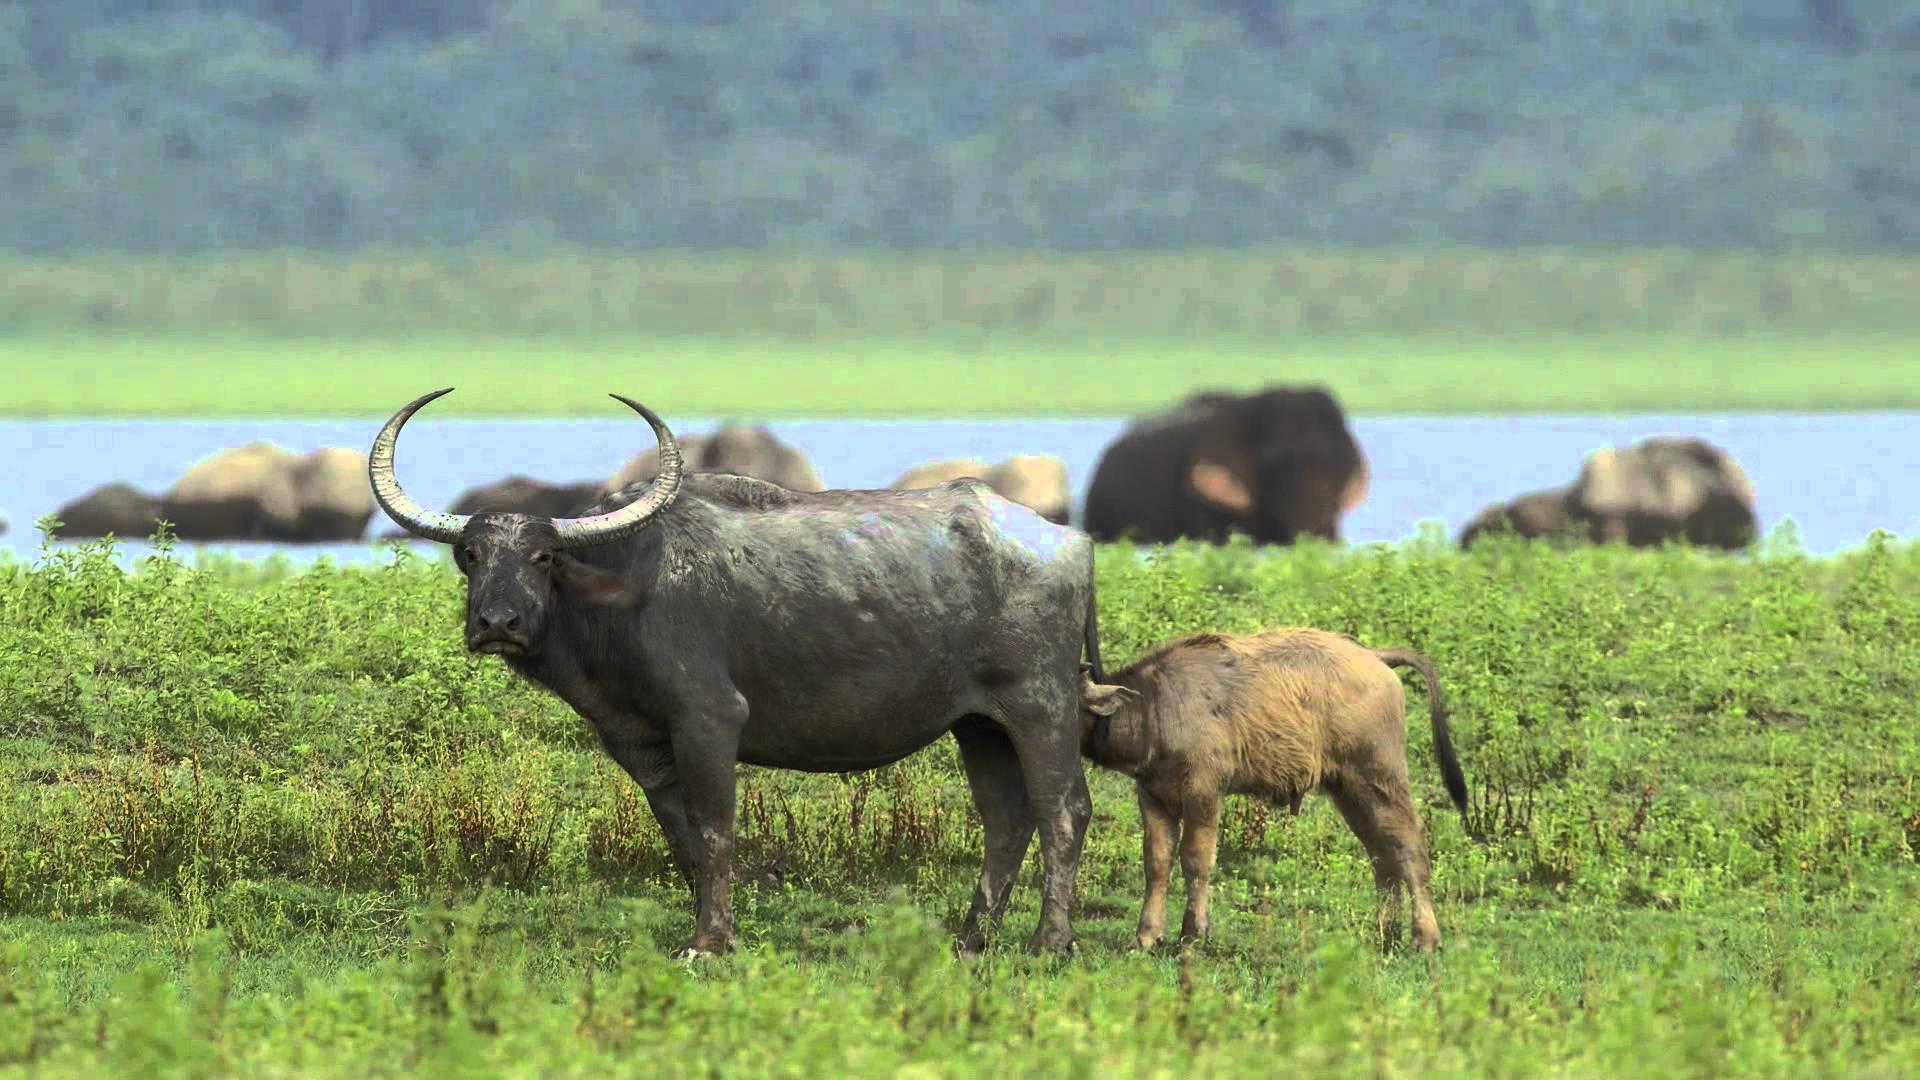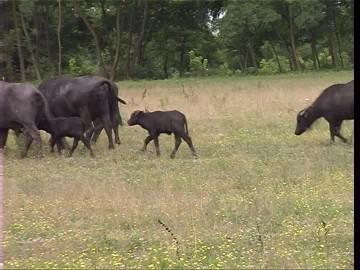The first image is the image on the left, the second image is the image on the right. Considering the images on both sides, is "There is an area of water seen behind some of the animals in the image on the left." valid? Answer yes or no. Yes. The first image is the image on the left, the second image is the image on the right. Evaluate the accuracy of this statement regarding the images: "An image shows water buffalo standing with a pool of water behind them, but not in front of them.". Is it true? Answer yes or no. Yes. 